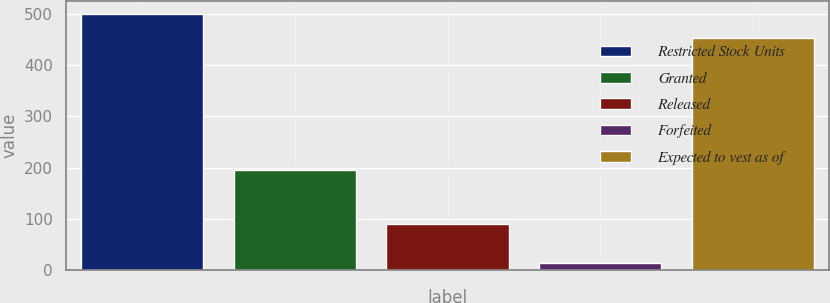Convert chart. <chart><loc_0><loc_0><loc_500><loc_500><bar_chart><fcel>Restricted Stock Units<fcel>Granted<fcel>Released<fcel>Forfeited<fcel>Expected to vest as of<nl><fcel>500.2<fcel>196<fcel>91<fcel>14<fcel>452.1<nl></chart> 